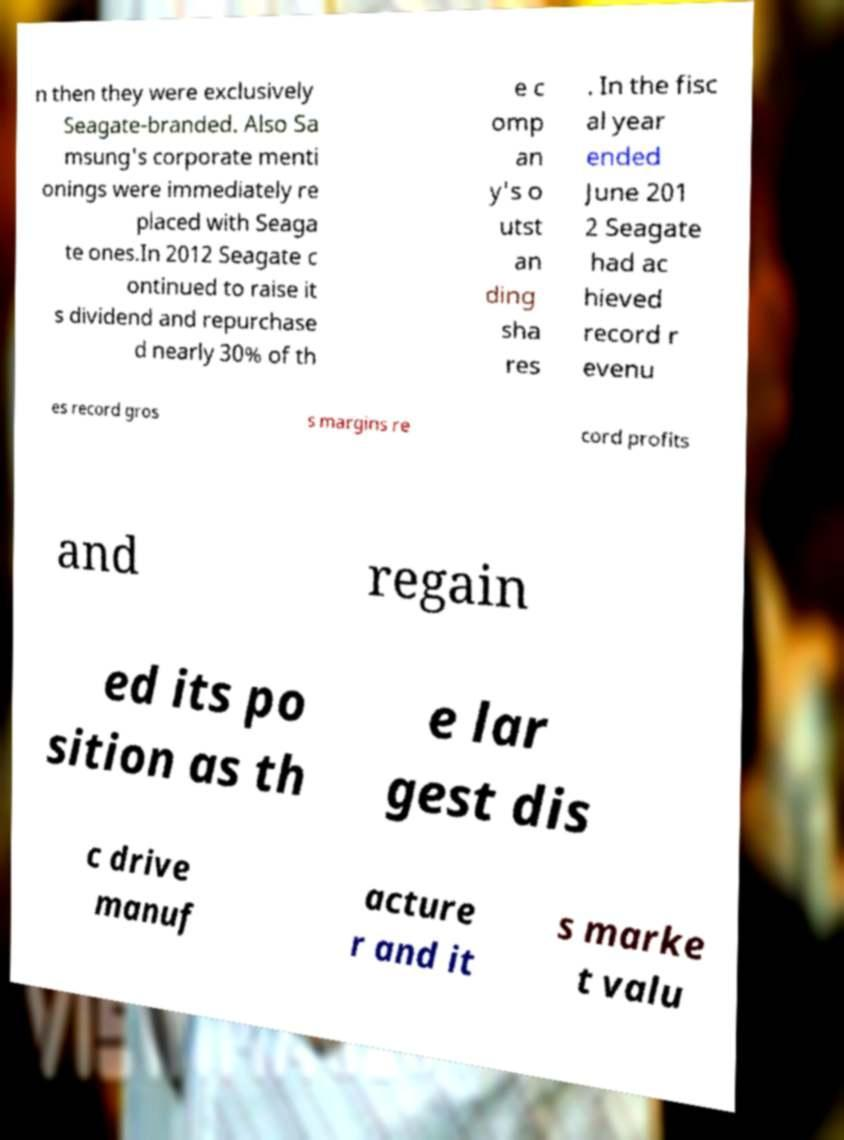There's text embedded in this image that I need extracted. Can you transcribe it verbatim? n then they were exclusively Seagate-branded. Also Sa msung's corporate menti onings were immediately re placed with Seaga te ones.In 2012 Seagate c ontinued to raise it s dividend and repurchase d nearly 30% of th e c omp an y's o utst an ding sha res . In the fisc al year ended June 201 2 Seagate had ac hieved record r evenu es record gros s margins re cord profits and regain ed its po sition as th e lar gest dis c drive manuf acture r and it s marke t valu 